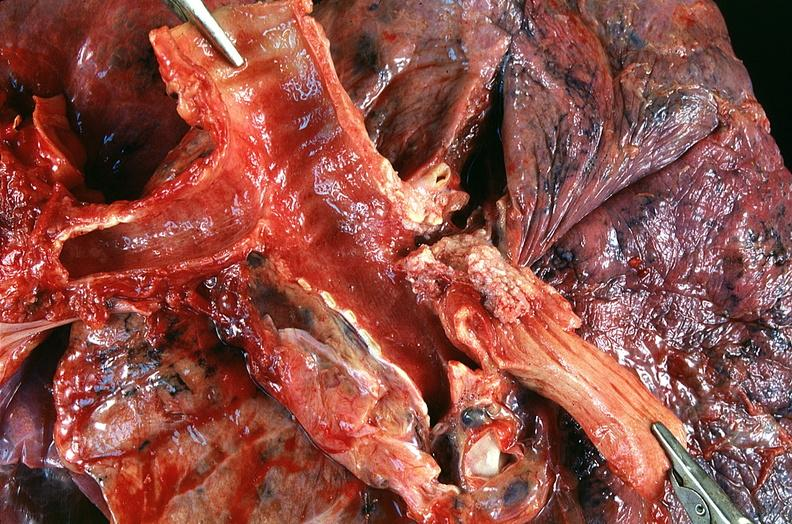s respiratory present?
Answer the question using a single word or phrase. Yes 